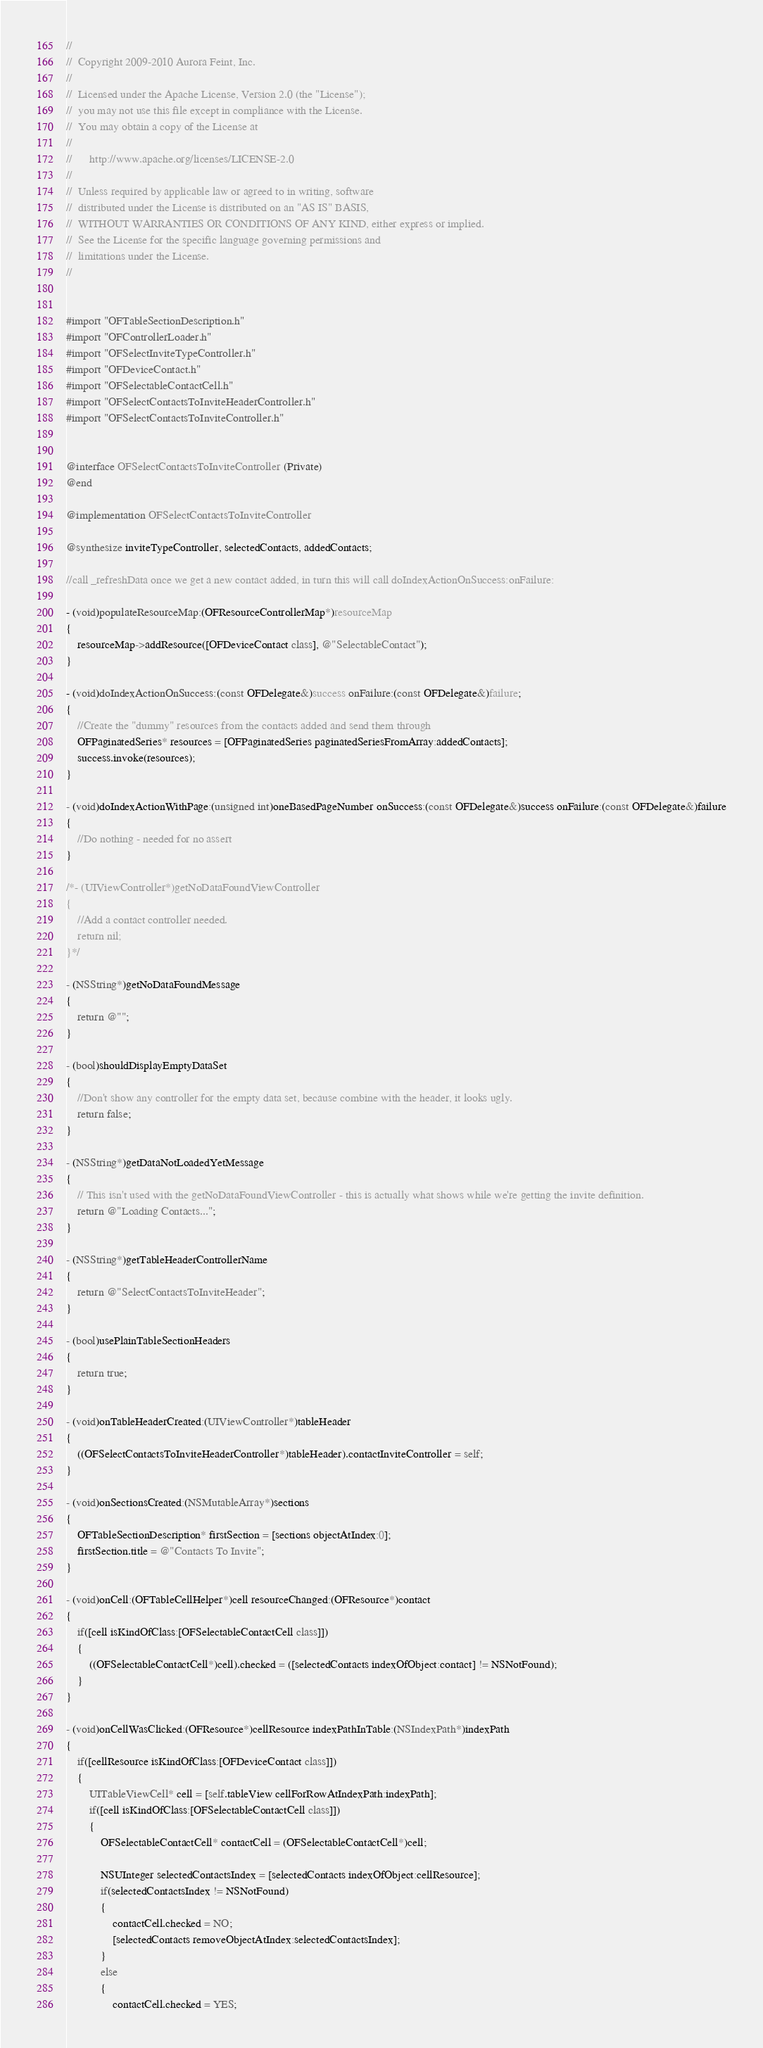Convert code to text. <code><loc_0><loc_0><loc_500><loc_500><_ObjectiveC_>// 
//  Copyright 2009-2010 Aurora Feint, Inc.
// 
//  Licensed under the Apache License, Version 2.0 (the "License");
//  you may not use this file except in compliance with the License.
//  You may obtain a copy of the License at
//  
//  	http://www.apache.org/licenses/LICENSE-2.0
//  	
//  Unless required by applicable law or agreed to in writing, software
//  distributed under the License is distributed on an "AS IS" BASIS,
//  WITHOUT WARRANTIES OR CONDITIONS OF ANY KIND, either express or implied.
//  See the License for the specific language governing permissions and
//  limitations under the License.
// 


#import "OFTableSectionDescription.h"
#import "OFControllerLoader.h"
#import "OFSelectInviteTypeController.h"
#import "OFDeviceContact.h"
#import "OFSelectableContactCell.h"
#import "OFSelectContactsToInviteHeaderController.h"
#import "OFSelectContactsToInviteController.h"


@interface OFSelectContactsToInviteController (Private)
@end

@implementation OFSelectContactsToInviteController

@synthesize inviteTypeController, selectedContacts, addedContacts;

//call _refreshData once we get a new contact added, in turn this will call doIndexActionOnSuccess:onFailure:

- (void)populateResourceMap:(OFResourceControllerMap*)resourceMap
{
	resourceMap->addResource([OFDeviceContact class], @"SelectableContact");
}

- (void)doIndexActionOnSuccess:(const OFDelegate&)success onFailure:(const OFDelegate&)failure;
{
	//Create the "dummy" resources from the contacts added and send them through
	OFPaginatedSeries* resources = [OFPaginatedSeries paginatedSeriesFromArray:addedContacts];
	success.invoke(resources);
}

- (void)doIndexActionWithPage:(unsigned int)oneBasedPageNumber onSuccess:(const OFDelegate&)success onFailure:(const OFDelegate&)failure
{
	//Do nothing - needed for no assert
}

/*- (UIViewController*)getNoDataFoundViewController
{
	//Add a contact controller needed.
	return nil;
}*/

- (NSString*)getNoDataFoundMessage
{
	return @"";
}

- (bool)shouldDisplayEmptyDataSet
{
	//Don't show any controller for the empty data set, because combine with the header, it looks ugly.
	return false;
}

- (NSString*)getDataNotLoadedYetMessage
{
	// This isn't used with the getNoDataFoundViewController - this is actually what shows while we're getting the invite definition.
	return @"Loading Contacts...";
}

- (NSString*)getTableHeaderControllerName
{
	return @"SelectContactsToInviteHeader";
}

- (bool)usePlainTableSectionHeaders
{
	return true;
}

- (void)onTableHeaderCreated:(UIViewController*)tableHeader
{
	((OFSelectContactsToInviteHeaderController*)tableHeader).contactInviteController = self;
}

- (void)onSectionsCreated:(NSMutableArray*)sections
{
	OFTableSectionDescription* firstSection = [sections objectAtIndex:0];
	firstSection.title = @"Contacts To Invite";
}

- (void)onCell:(OFTableCellHelper*)cell resourceChanged:(OFResource*)contact
{
	if([cell isKindOfClass:[OFSelectableContactCell class]])
	{
		((OFSelectableContactCell*)cell).checked = ([selectedContacts indexOfObject:contact] != NSNotFound);
	}
}

- (void)onCellWasClicked:(OFResource*)cellResource indexPathInTable:(NSIndexPath*)indexPath
{
	if([cellResource isKindOfClass:[OFDeviceContact class]])
	{
		UITableViewCell* cell = [self.tableView cellForRowAtIndexPath:indexPath];
		if([cell isKindOfClass:[OFSelectableContactCell class]])
		{
			OFSelectableContactCell* contactCell = (OFSelectableContactCell*)cell;
			
			NSUInteger selectedContactsIndex = [selectedContacts indexOfObject:cellResource];
			if(selectedContactsIndex != NSNotFound)
			{
				contactCell.checked = NO;
				[selectedContacts removeObjectAtIndex:selectedContactsIndex];
			}
			else
			{
				contactCell.checked = YES;</code> 